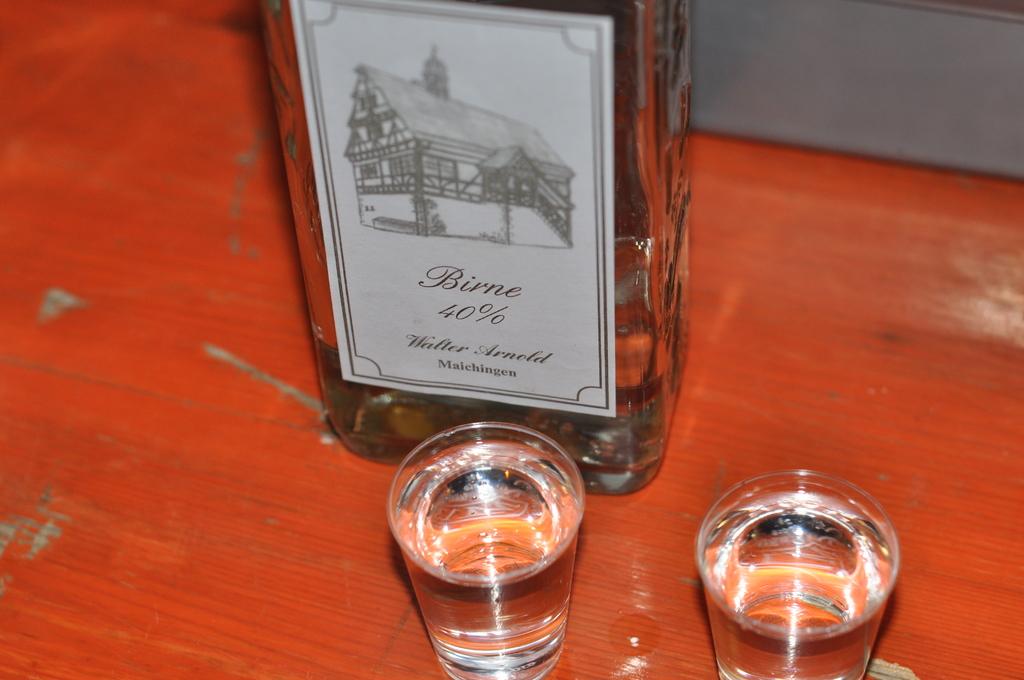What's the percentage on the bottle?
Give a very brief answer. 40. 